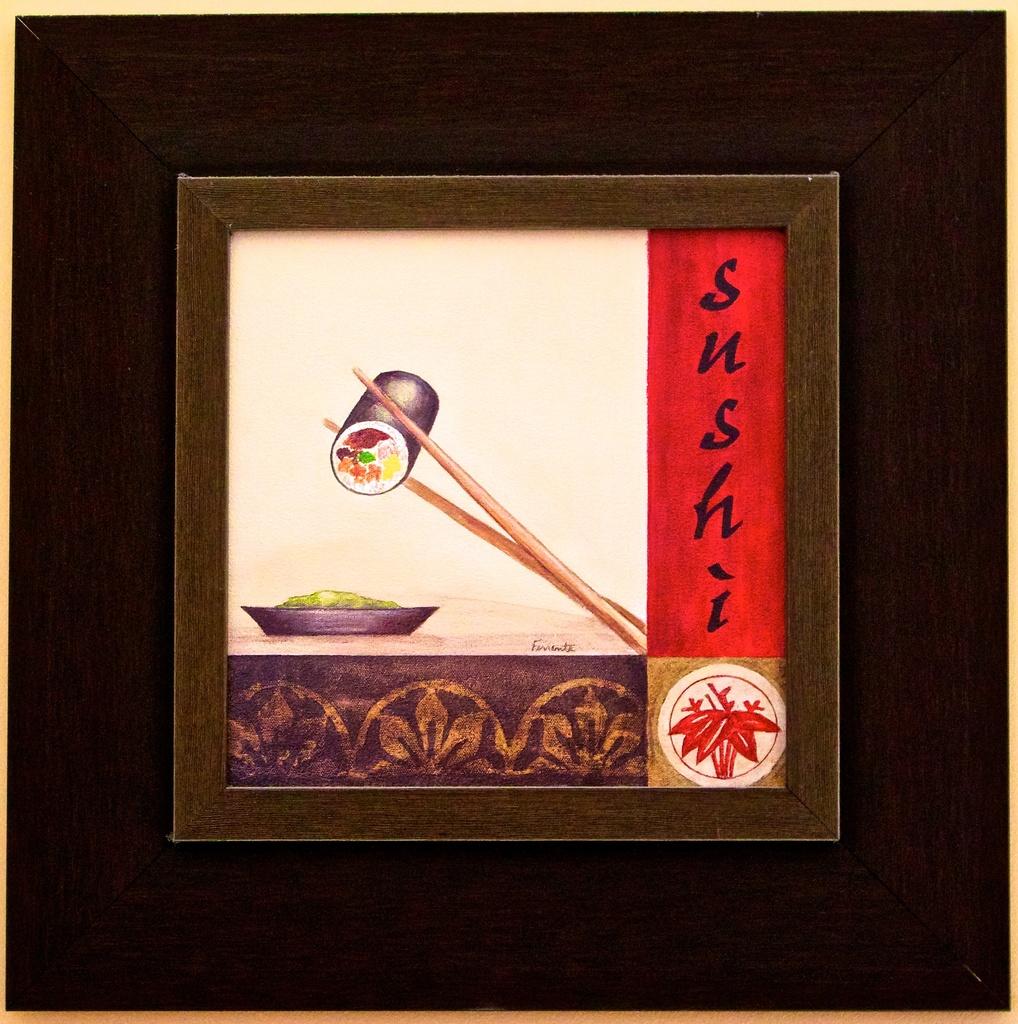Is this sushi?
Provide a succinct answer. Yes. What does it say next to the art?
Keep it short and to the point. Sushi. 